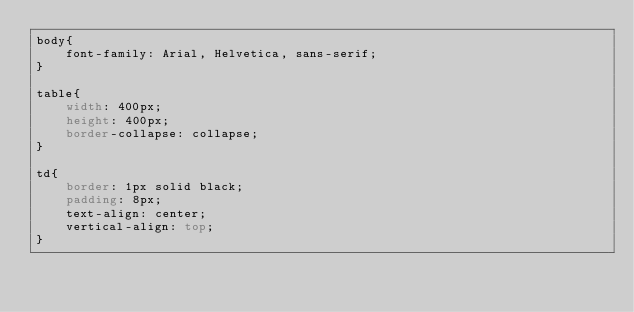<code> <loc_0><loc_0><loc_500><loc_500><_CSS_>body{
    font-family: Arial, Helvetica, sans-serif;
}

table{
    width: 400px;
    height: 400px;
    border-collapse: collapse;
}

td{
    border: 1px solid black;
    padding: 8px;
    text-align: center; 
    vertical-align: top;
}</code> 